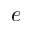<formula> <loc_0><loc_0><loc_500><loc_500>e</formula> 